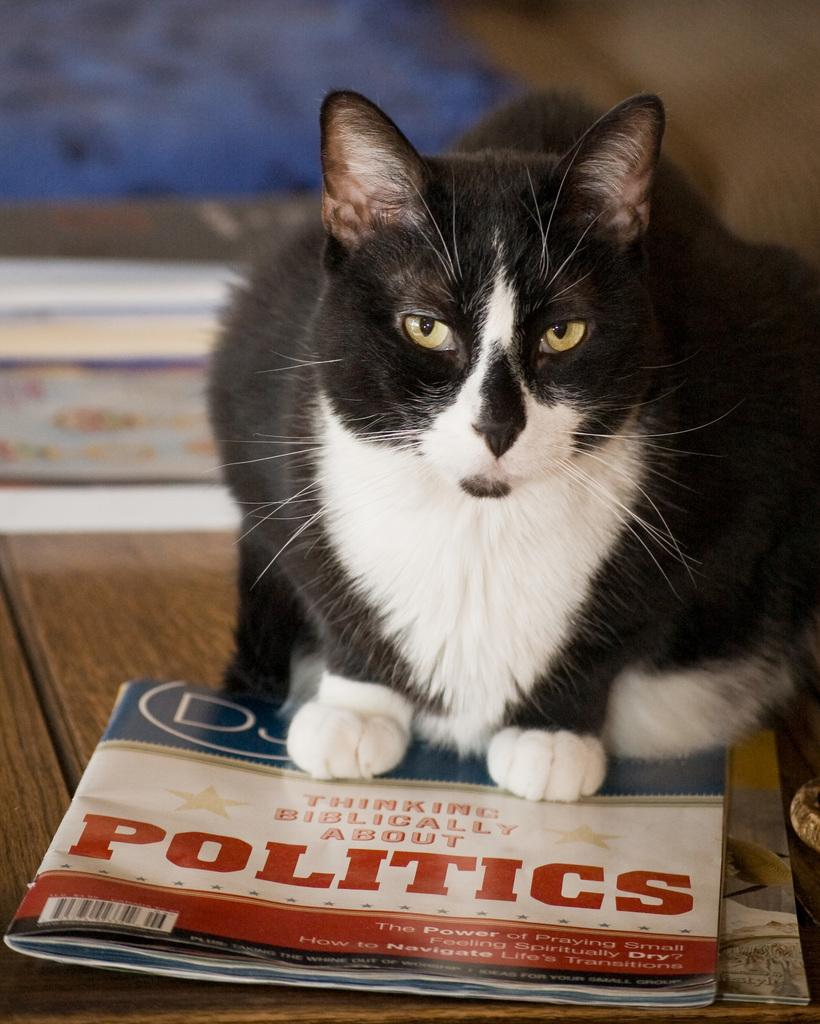<image>
Render a clear and concise summary of the photo. A black and white cat sits on a politics magazine. 